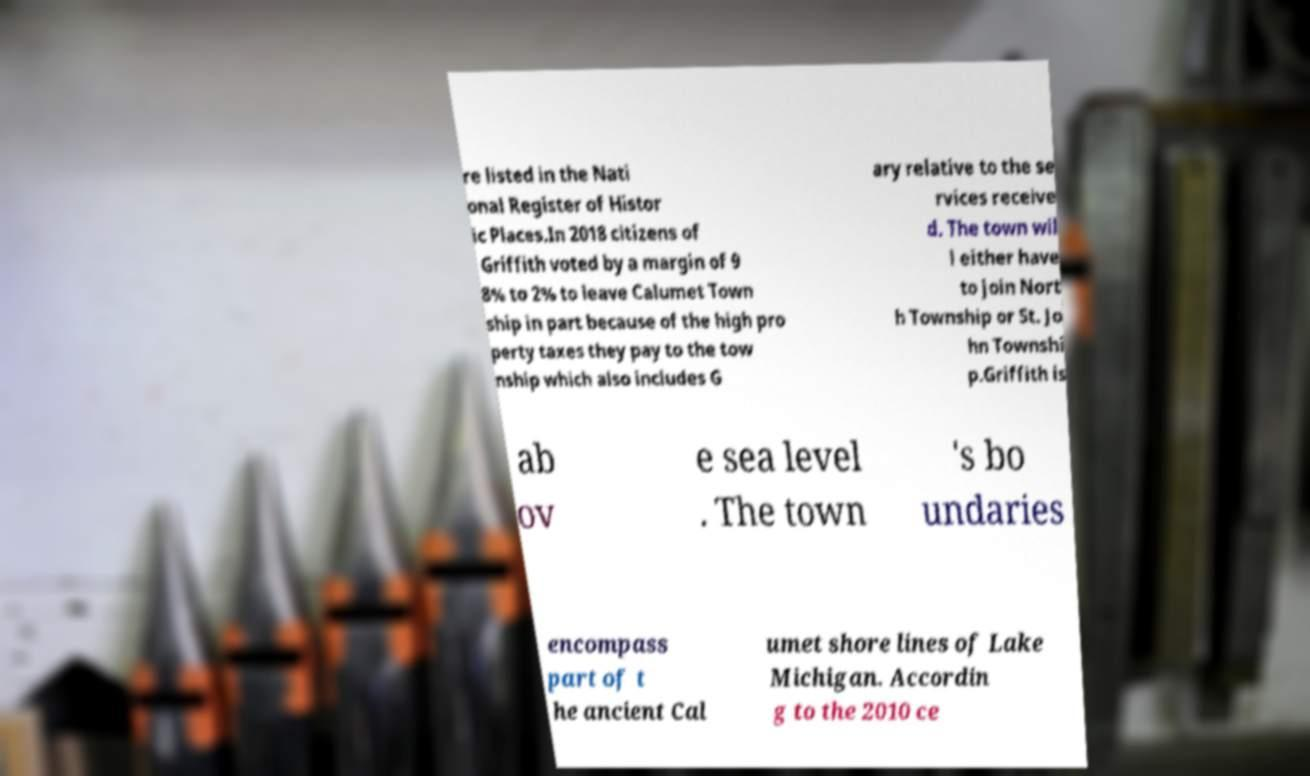Could you assist in decoding the text presented in this image and type it out clearly? re listed in the Nati onal Register of Histor ic Places.In 2018 citizens of Griffith voted by a margin of 9 8% to 2% to leave Calumet Town ship in part because of the high pro perty taxes they pay to the tow nship which also includes G ary relative to the se rvices receive d. The town wil l either have to join Nort h Township or St. Jo hn Townshi p.Griffith is ab ov e sea level . The town 's bo undaries encompass part of t he ancient Cal umet shore lines of Lake Michigan. Accordin g to the 2010 ce 